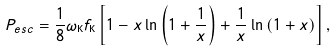<formula> <loc_0><loc_0><loc_500><loc_500>P _ { e s c } = \frac { 1 } { 8 } \omega _ { \mathrm K } f _ { \mathrm K } \left [ 1 - x \ln \left ( 1 + \frac { 1 } { x } \right ) + \frac { 1 } { x } \ln \left ( 1 + x \right ) \right ] ,</formula> 